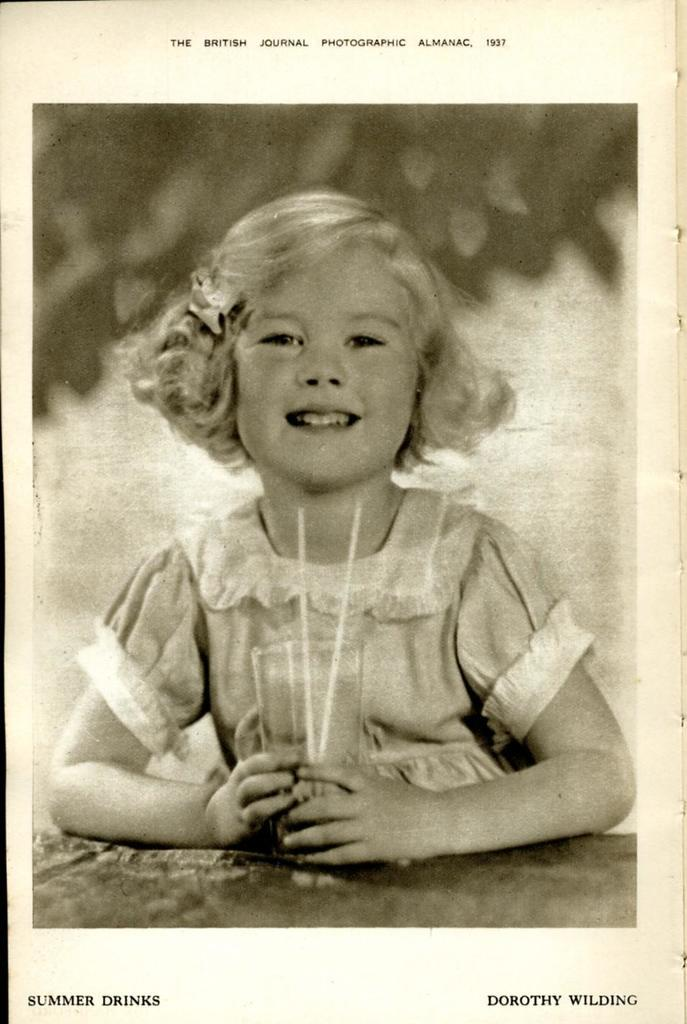What is the color scheme of the image? The image is black and white. Who is present in the image? There is a girl in the image. What is the girl holding in the image? The girl is holding a glass. How many straws are in the glass? There are two straws in the glass. Where can text be found in the image? There is text at the bottom and top of the image. What type of engine is visible in the image? There is no engine present in the image. What kind of humor can be seen in the text at the top of the image? There is no humor in the text at the top of the image, as the image is black and white and does not contain any humorous elements. 